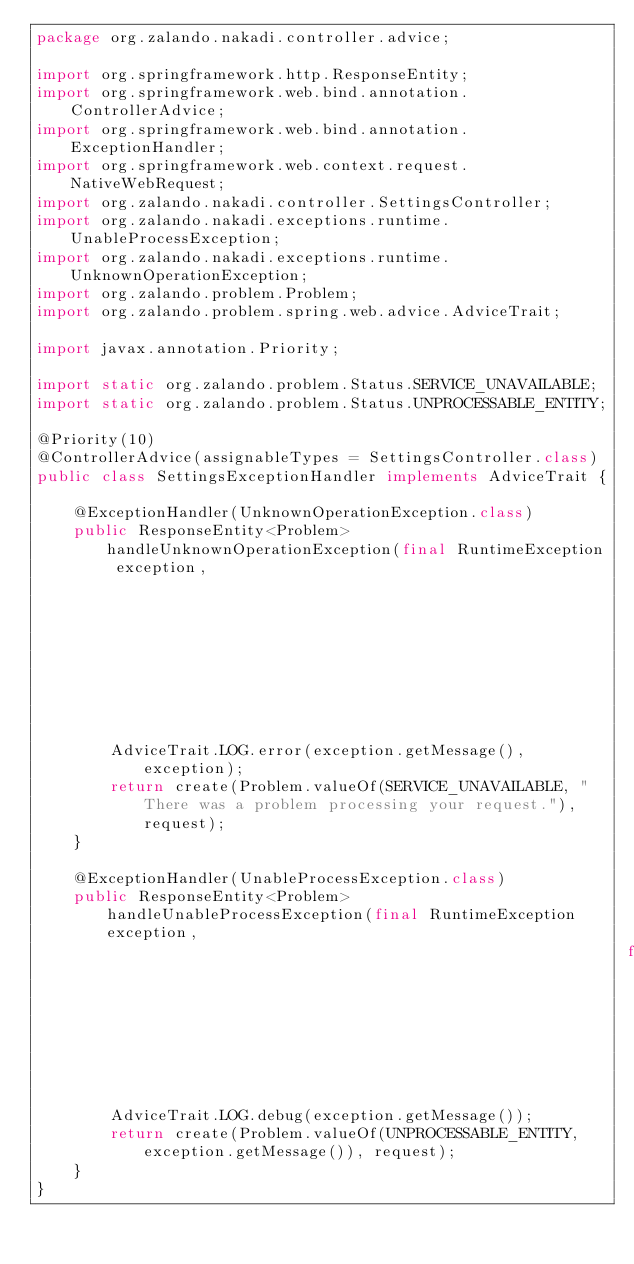Convert code to text. <code><loc_0><loc_0><loc_500><loc_500><_Java_>package org.zalando.nakadi.controller.advice;

import org.springframework.http.ResponseEntity;
import org.springframework.web.bind.annotation.ControllerAdvice;
import org.springframework.web.bind.annotation.ExceptionHandler;
import org.springframework.web.context.request.NativeWebRequest;
import org.zalando.nakadi.controller.SettingsController;
import org.zalando.nakadi.exceptions.runtime.UnableProcessException;
import org.zalando.nakadi.exceptions.runtime.UnknownOperationException;
import org.zalando.problem.Problem;
import org.zalando.problem.spring.web.advice.AdviceTrait;

import javax.annotation.Priority;

import static org.zalando.problem.Status.SERVICE_UNAVAILABLE;
import static org.zalando.problem.Status.UNPROCESSABLE_ENTITY;

@Priority(10)
@ControllerAdvice(assignableTypes = SettingsController.class)
public class SettingsExceptionHandler implements AdviceTrait {

    @ExceptionHandler(UnknownOperationException.class)
    public ResponseEntity<Problem> handleUnknownOperationException(final RuntimeException exception,
                                                                   final NativeWebRequest request) {
        AdviceTrait.LOG.error(exception.getMessage(), exception);
        return create(Problem.valueOf(SERVICE_UNAVAILABLE, "There was a problem processing your request."), request);
    }

    @ExceptionHandler(UnableProcessException.class)
    public ResponseEntity<Problem> handleUnableProcessException(final RuntimeException exception,
                                                                final NativeWebRequest request) {
        AdviceTrait.LOG.debug(exception.getMessage());
        return create(Problem.valueOf(UNPROCESSABLE_ENTITY, exception.getMessage()), request);
    }
}
</code> 